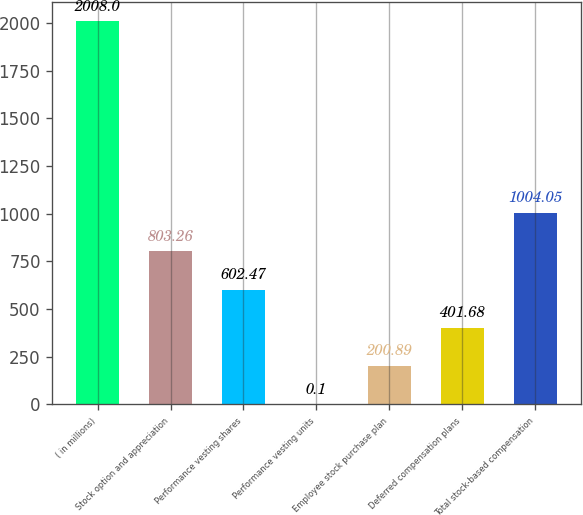Convert chart to OTSL. <chart><loc_0><loc_0><loc_500><loc_500><bar_chart><fcel>( in millions)<fcel>Stock option and appreciation<fcel>Performance vesting shares<fcel>Performance vesting units<fcel>Employee stock purchase plan<fcel>Deferred compensation plans<fcel>Total stock-based compensation<nl><fcel>2008<fcel>803.26<fcel>602.47<fcel>0.1<fcel>200.89<fcel>401.68<fcel>1004.05<nl></chart> 